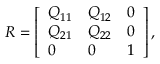<formula> <loc_0><loc_0><loc_500><loc_500>\begin{array} { r } { R = \left [ \begin{array} { l l l } { Q _ { 1 1 } } & { Q _ { 1 2 } } & { 0 } \\ { Q _ { 2 1 } } & { Q _ { 2 2 } } & { 0 } \\ { 0 } & { 0 } & { 1 } \end{array} \right ] , } \end{array}</formula> 